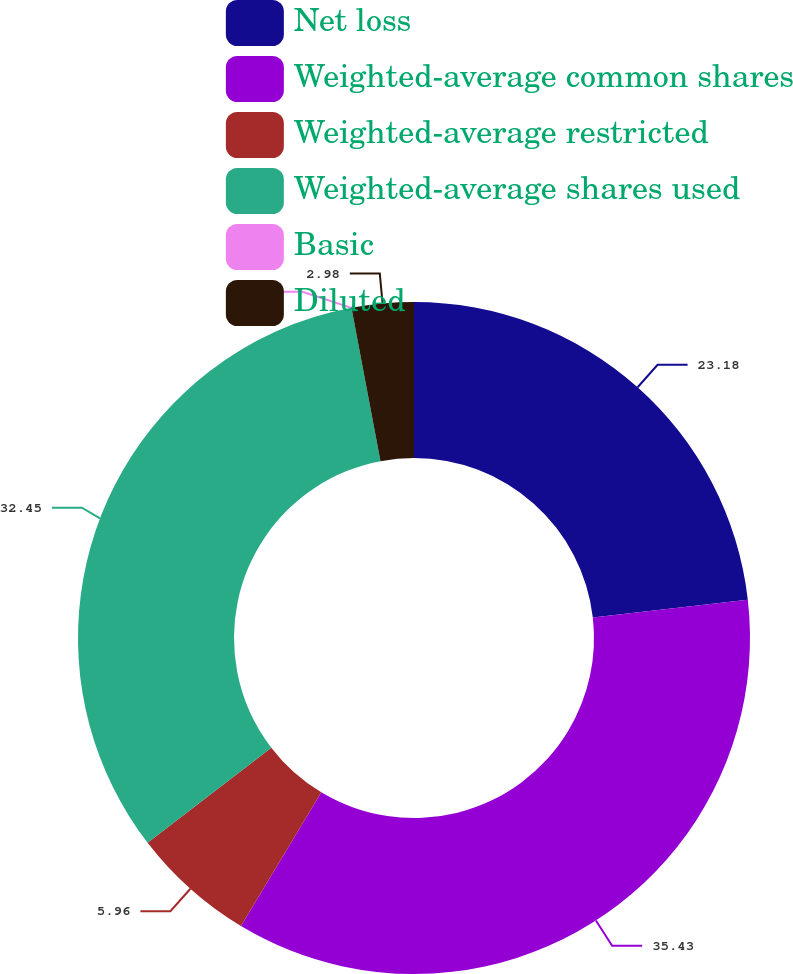Convert chart to OTSL. <chart><loc_0><loc_0><loc_500><loc_500><pie_chart><fcel>Net loss<fcel>Weighted-average common shares<fcel>Weighted-average restricted<fcel>Weighted-average shares used<fcel>Basic<fcel>Diluted<nl><fcel>23.18%<fcel>35.43%<fcel>5.96%<fcel>32.45%<fcel>0.0%<fcel>2.98%<nl></chart> 